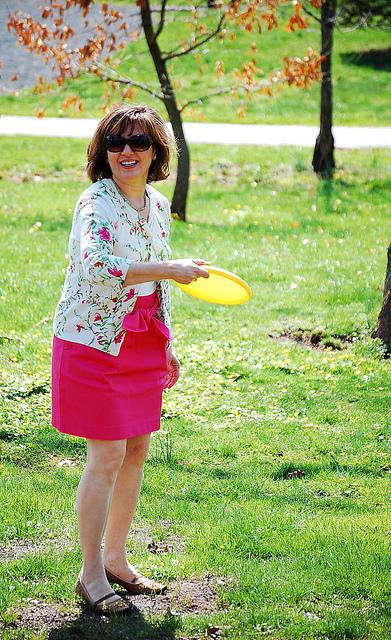Is this woman dressed as a person who is emo?
Be succinct. No. What is the woman holding in her hand?
Answer briefly. Frisbee. What is the woman wearing?
Answer briefly. Skirt. 